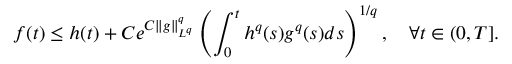<formula> <loc_0><loc_0><loc_500><loc_500>f ( t ) \leq h ( t ) + C e ^ { C \| g \| _ { L ^ { q } } ^ { q } } \left ( \int _ { 0 } ^ { t } h ^ { q } ( s ) g ^ { q } ( s ) d s \right ) ^ { 1 / q } , \quad \forall t \in ( 0 , T ] .</formula> 